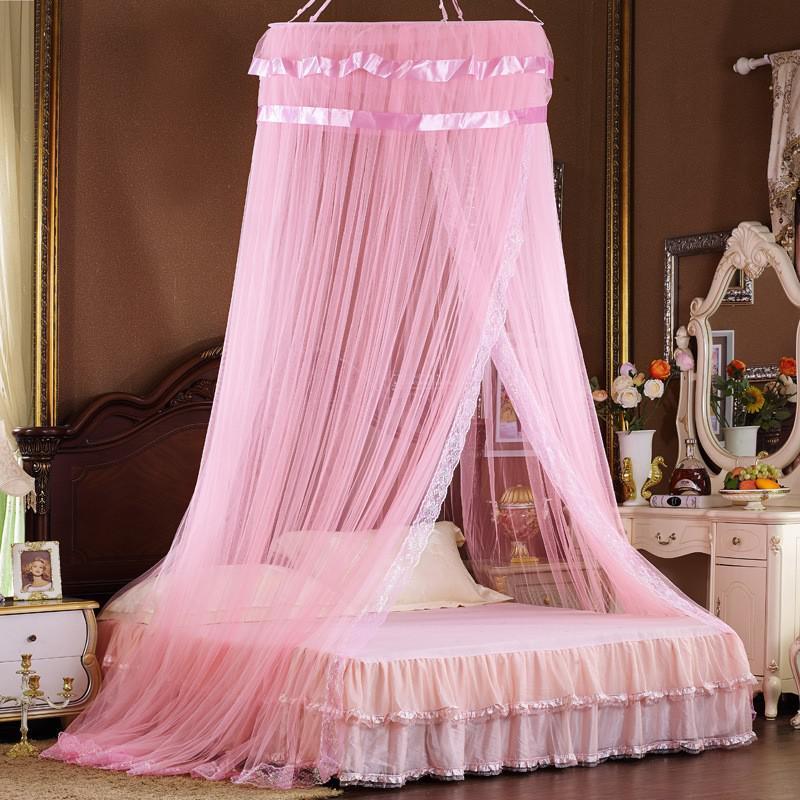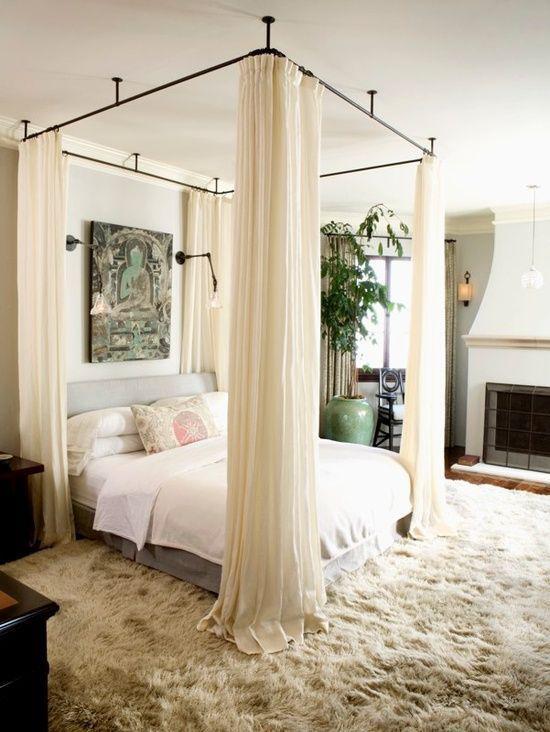The first image is the image on the left, the second image is the image on the right. Examine the images to the left and right. Is the description "At least one bed has a pink canopy." accurate? Answer yes or no. Yes. The first image is the image on the left, the second image is the image on the right. Given the left and right images, does the statement "There is a table lamp in the image on the left." hold true? Answer yes or no. No. 